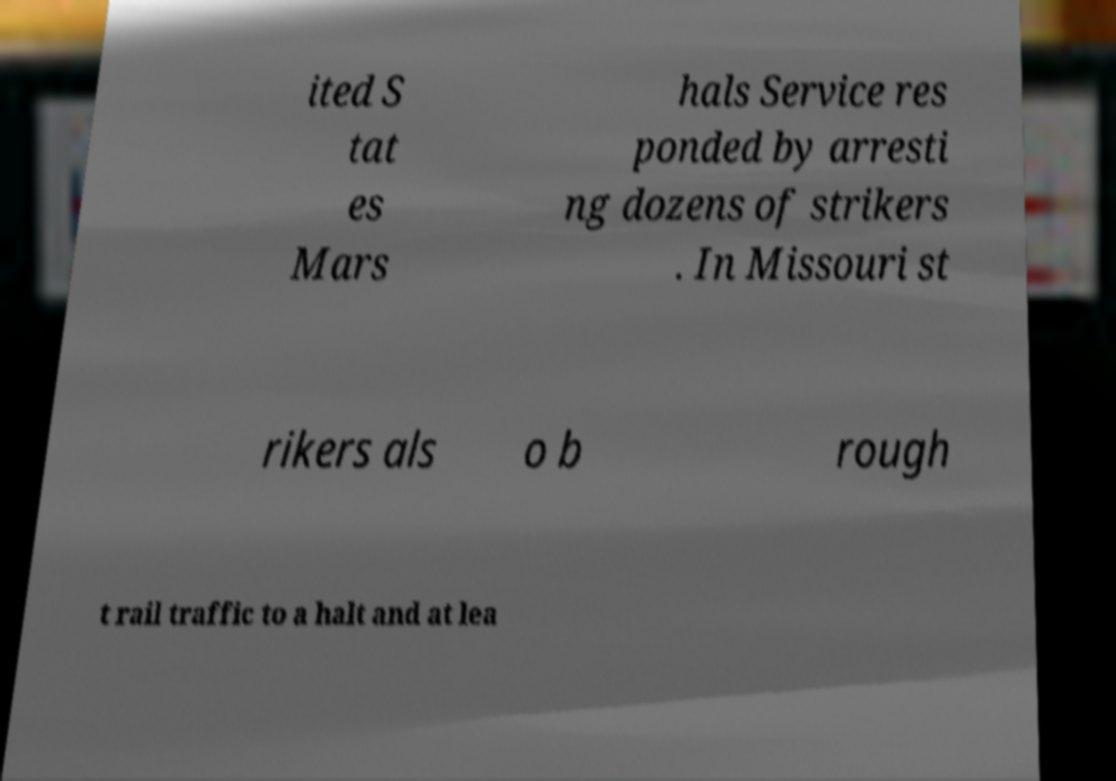Please read and relay the text visible in this image. What does it say? ited S tat es Mars hals Service res ponded by arresti ng dozens of strikers . In Missouri st rikers als o b rough t rail traffic to a halt and at lea 